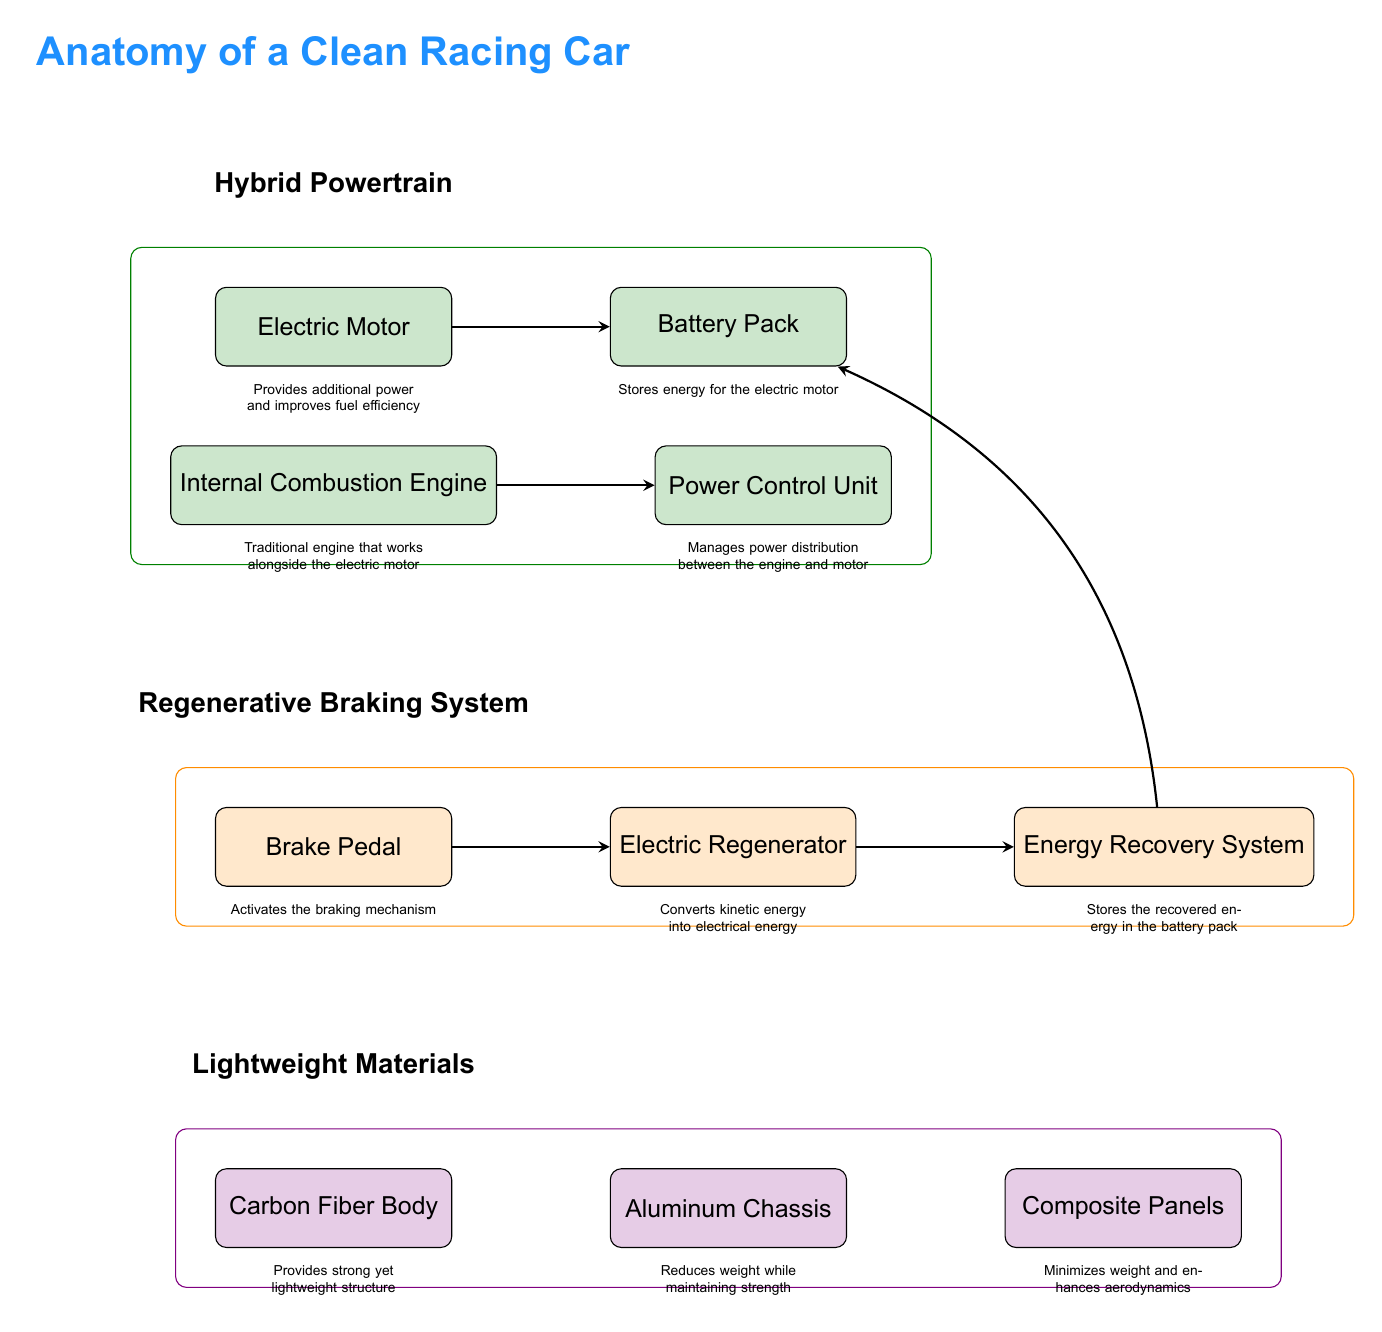What is the first component listed under the hybrid powertrain section? The first component listed under the hybrid powertrain section is the electric motor, as it appears directly under the "Hybrid Powertrain" title in the diagram.
Answer: Electric Motor How many components are there in the lightweight materials section? There are three components in the lightweight materials section: Carbon Fiber Body, Aluminum Chassis, and Composite Panels, as seen directly under the "Lightweight Materials" title in the diagram.
Answer: Three What is the function of the brake pedal? The brake pedal activates the braking mechanism, which is noted in the description under the "Regenerative Braking System" section.
Answer: Activates the braking mechanism Which component converts kinetic energy into electrical energy? The Electric Regenerator converts kinetic energy into electrical energy, as indicated in the diagram under the Regenerative Braking System section.
Answer: Electric Regenerator What color is used for the hybrid powertrain section? The hybrid powertrain section is colored in a shade designated by the variable hybridcolor, which is a light green color in the diagram.
Answer: Light green What does the Power Control Unit do? The Power Control Unit manages power distribution between the internal combustion engine and the electric motor, according to the descriptions connected to it in the diagram.
Answer: Manages power distribution How does the Energy Recovery System relate to the battery pack? The Energy Recovery System stores the recovered energy back into the battery pack, as indicated by the arrow flowing from the Electric Regenerator to the Energy Recovery System, then to the Battery Pack.
Answer: Stores energy in the battery pack Which material provides a strong yet lightweight structure? The Carbon Fiber Body is identified as providing a strong yet lightweight structure, as described under lightweight materials.
Answer: Carbon Fiber Body What component supports the chassis in reducing weight? The Aluminum Chassis supports the function of reducing weight while maintaining strength, as noted in the diagram beneath the Lightweight Materials section.
Answer: Aluminum Chassis 